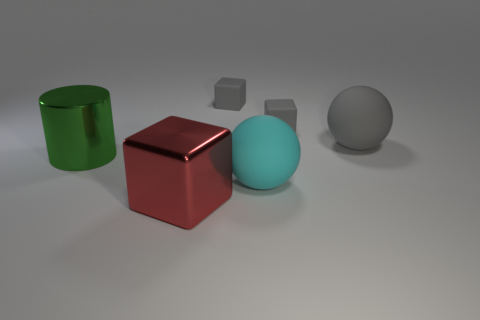Subtract all matte cubes. How many cubes are left? 1 Subtract all cyan cylinders. How many gray blocks are left? 2 Subtract all cyan balls. How many balls are left? 1 Add 2 matte things. How many objects exist? 8 Subtract all cylinders. How many objects are left? 5 Subtract all blue cubes. Subtract all purple cylinders. How many cubes are left? 3 Subtract 0 yellow cylinders. How many objects are left? 6 Subtract all big yellow rubber cylinders. Subtract all metal objects. How many objects are left? 4 Add 1 small gray cubes. How many small gray cubes are left? 3 Add 1 big rubber spheres. How many big rubber spheres exist? 3 